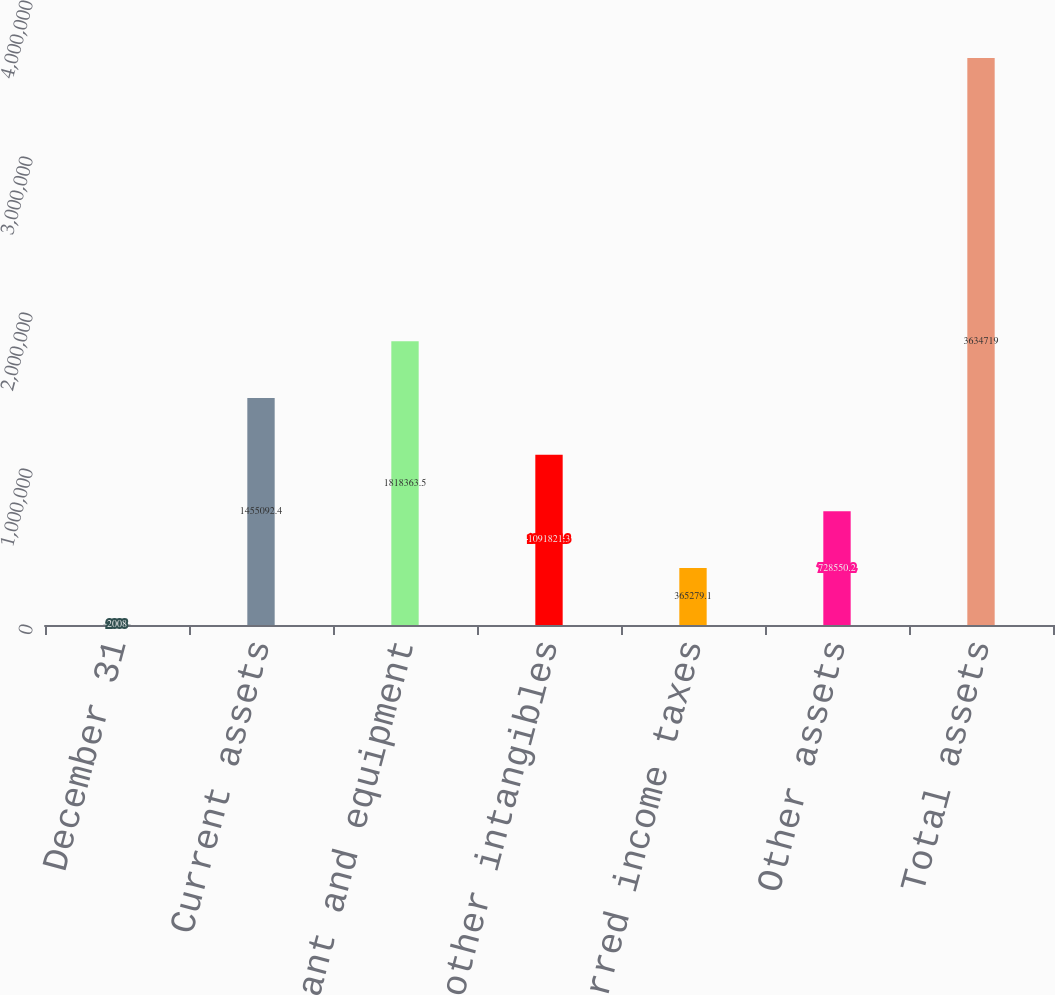Convert chart to OTSL. <chart><loc_0><loc_0><loc_500><loc_500><bar_chart><fcel>December 31<fcel>Current assets<fcel>Property plant and equipment<fcel>Goodwill and other intangibles<fcel>Deferred income taxes<fcel>Other assets<fcel>Total assets<nl><fcel>2008<fcel>1.45509e+06<fcel>1.81836e+06<fcel>1.09182e+06<fcel>365279<fcel>728550<fcel>3.63472e+06<nl></chart> 